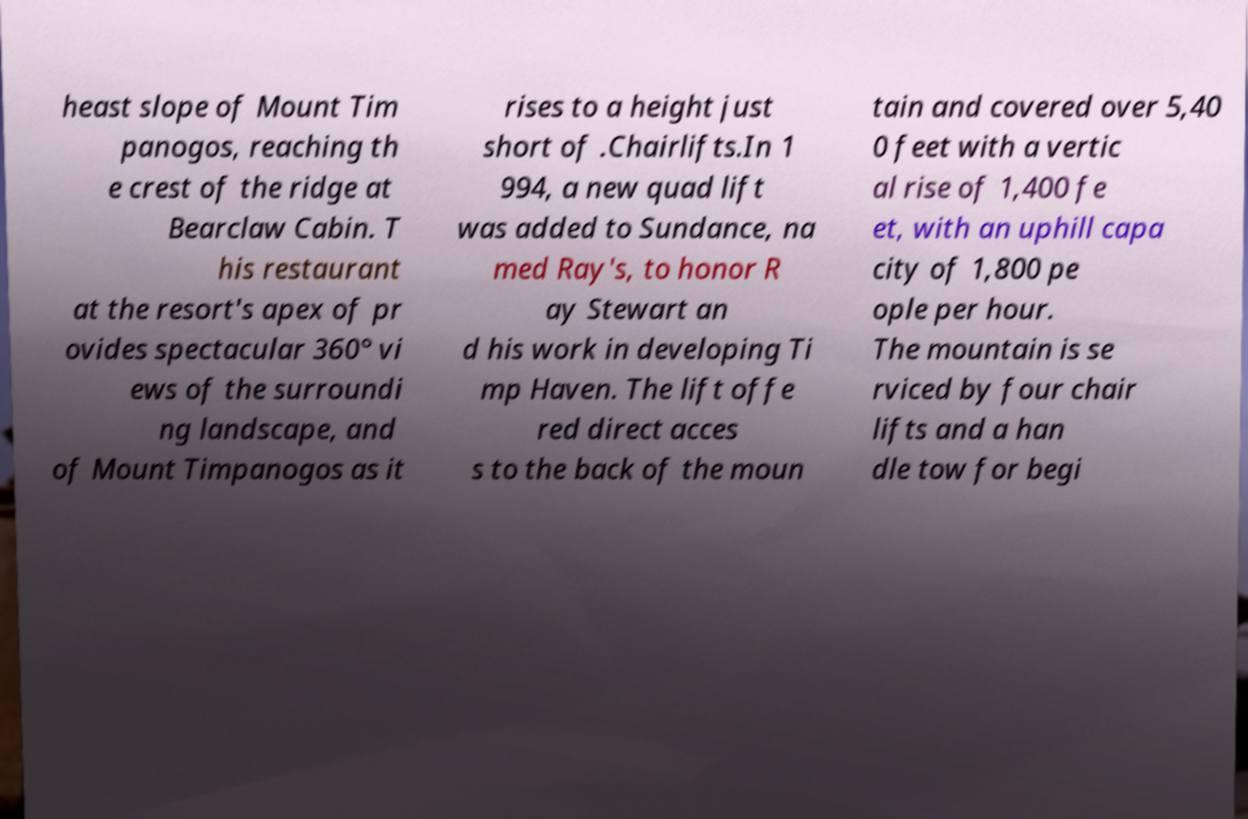Please identify and transcribe the text found in this image. heast slope of Mount Tim panogos, reaching th e crest of the ridge at Bearclaw Cabin. T his restaurant at the resort's apex of pr ovides spectacular 360° vi ews of the surroundi ng landscape, and of Mount Timpanogos as it rises to a height just short of .Chairlifts.In 1 994, a new quad lift was added to Sundance, na med Ray's, to honor R ay Stewart an d his work in developing Ti mp Haven. The lift offe red direct acces s to the back of the moun tain and covered over 5,40 0 feet with a vertic al rise of 1,400 fe et, with an uphill capa city of 1,800 pe ople per hour. The mountain is se rviced by four chair lifts and a han dle tow for begi 